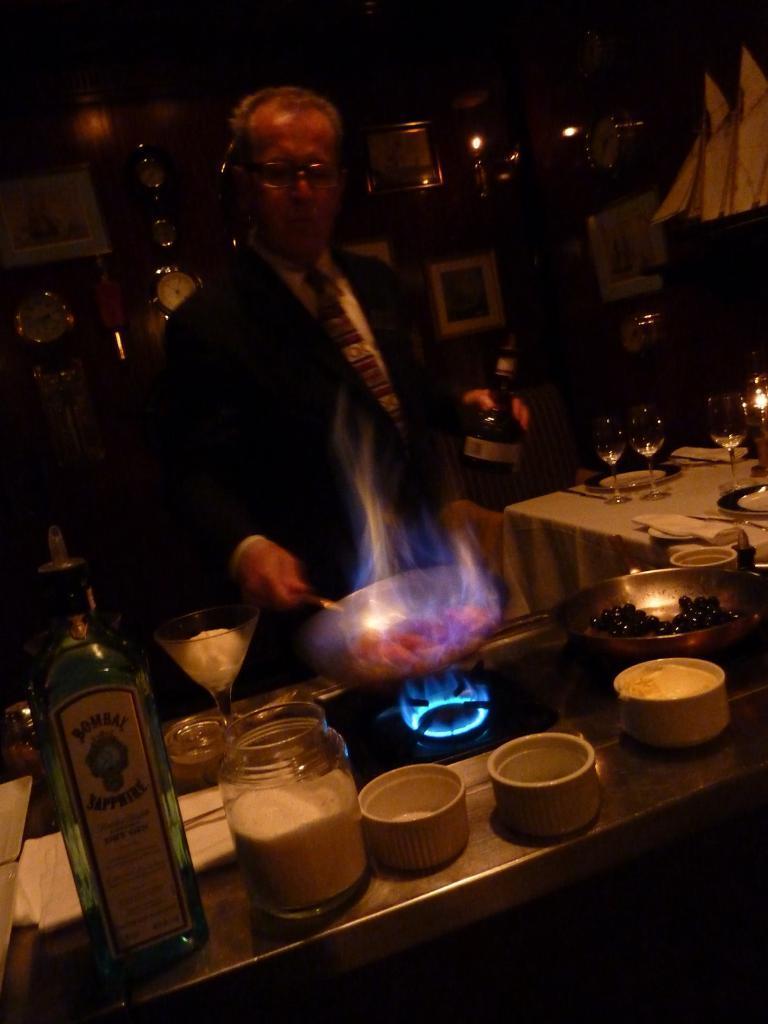Please provide a concise description of this image. In this image I can see the person standing and wearing the blazer. In-front of the person I can see the stove and the pan on it. To the side there are bottles, bowls, glasses and many objects on the counter top. In the back I can see some lights. 